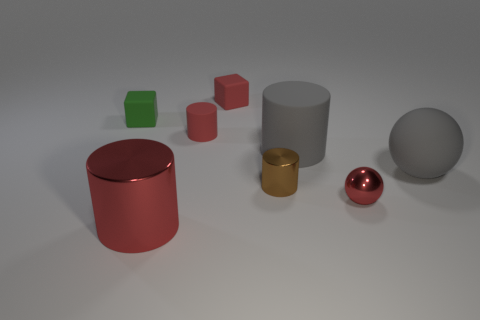What size is the thing that is left of the red matte cylinder and to the right of the green block?
Offer a terse response. Large. What number of other objects are the same shape as the brown metallic thing?
Your answer should be very brief. 3. How many blocks are tiny brown things or small things?
Offer a very short reply. 2. Is there a tiny red matte object that is in front of the large gray thing that is on the left side of the tiny shiny object right of the brown metallic cylinder?
Your answer should be compact. No. There is another small thing that is the same shape as the brown thing; what color is it?
Keep it short and to the point. Red. What number of cyan things are metallic objects or small cubes?
Provide a succinct answer. 0. There is a small cylinder that is left of the shiny cylinder that is to the right of the red matte cylinder; what is it made of?
Provide a short and direct response. Rubber. Is the shape of the green matte thing the same as the big metallic object?
Offer a very short reply. No. What color is the metallic sphere that is the same size as the green object?
Keep it short and to the point. Red. Are there any other cylinders of the same color as the small shiny cylinder?
Give a very brief answer. No. 